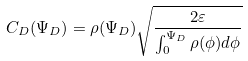<formula> <loc_0><loc_0><loc_500><loc_500>C _ { D } ( \Psi _ { D } ) = \rho ( \Psi _ { D } ) \sqrt { \frac { 2 \varepsilon } { \int _ { 0 } ^ { \Psi _ { D } } \rho ( \phi ) d \phi } }</formula> 